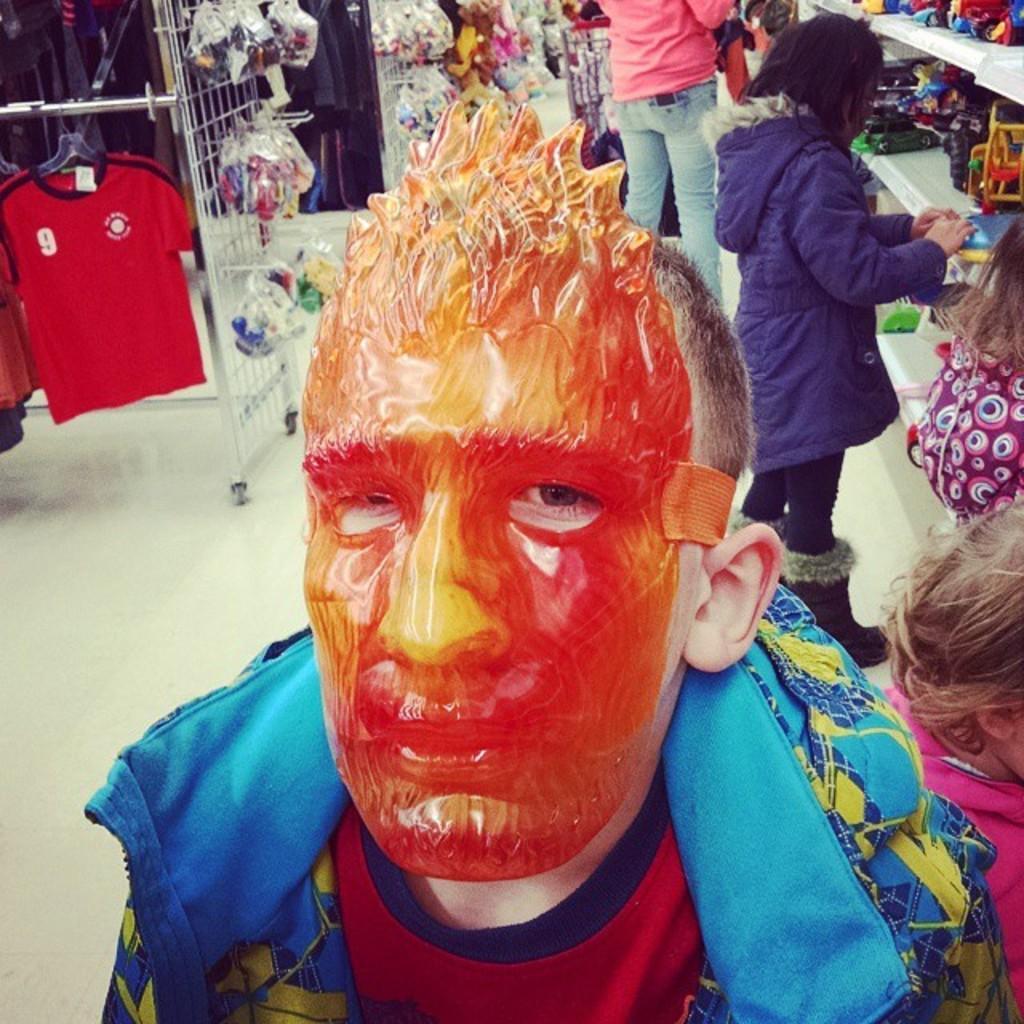Could you give a brief overview of what you see in this image? In the center of the image there is a person with mask on his face. On the right side of the image there are persons, toys placed in a racks. In the background there are toys, t-shirts, persons and floor. 